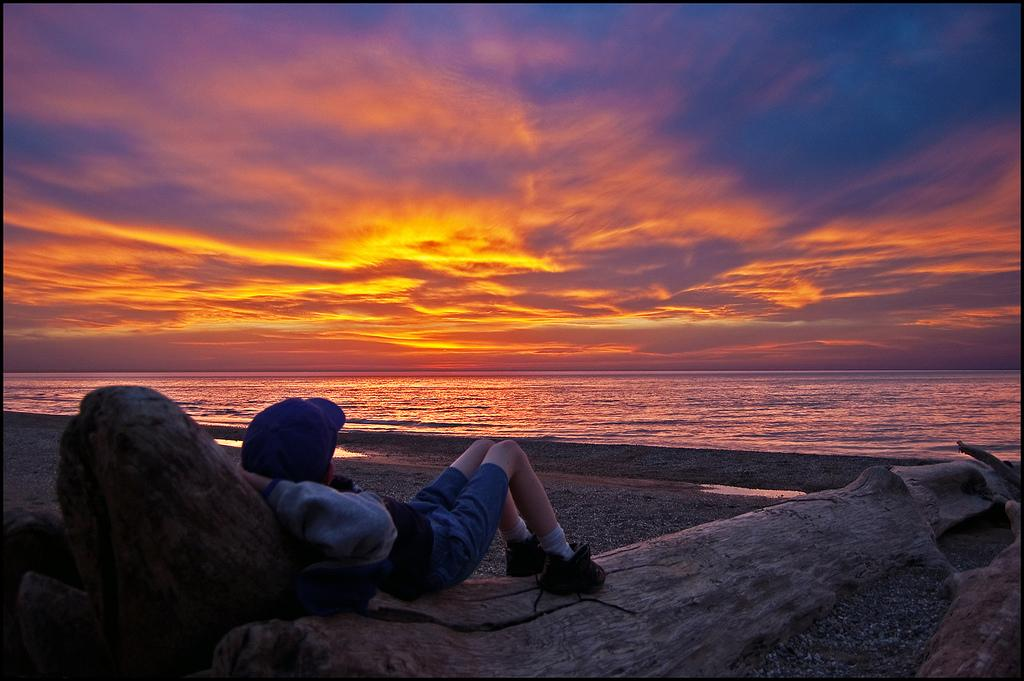What is the position of the human in the image? There is a human lying on the tree bark in the image. What can be seen in the background of the image? Water is visible in the image. What is the condition of the sky in the image? Sunlight is present in the sky. What type of surface is visible on the ground? There are stones on the ground. What shape is the basket in the image? There is no basket present in the image. 